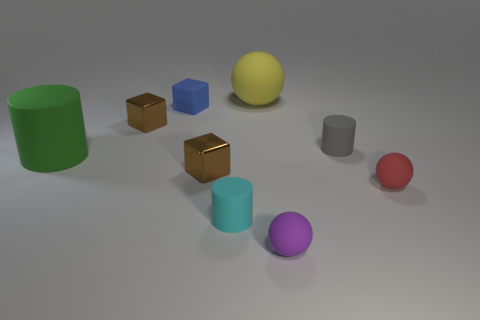There is a cyan object that is made of the same material as the yellow sphere; what shape is it?
Offer a terse response. Cylinder. Are there any other things that are the same shape as the gray object?
Your response must be concise. Yes. Are the big object in front of the big yellow sphere and the small purple thing made of the same material?
Your answer should be very brief. Yes. What is the small object that is in front of the small cyan thing made of?
Provide a short and direct response. Rubber. There is a metallic cube in front of the tiny brown metal block that is left of the tiny matte cube; what size is it?
Ensure brevity in your answer.  Small. How many brown shiny cubes have the same size as the green rubber cylinder?
Offer a terse response. 0. There is a tiny metallic object on the left side of the blue object; does it have the same color as the tiny matte cylinder to the right of the cyan matte thing?
Provide a short and direct response. No. There is a blue rubber cube; are there any tiny blue things behind it?
Provide a succinct answer. No. The tiny matte object that is to the left of the purple sphere and in front of the large green rubber cylinder is what color?
Your answer should be very brief. Cyan. Are there any metallic cubes of the same color as the large cylinder?
Keep it short and to the point. No. 